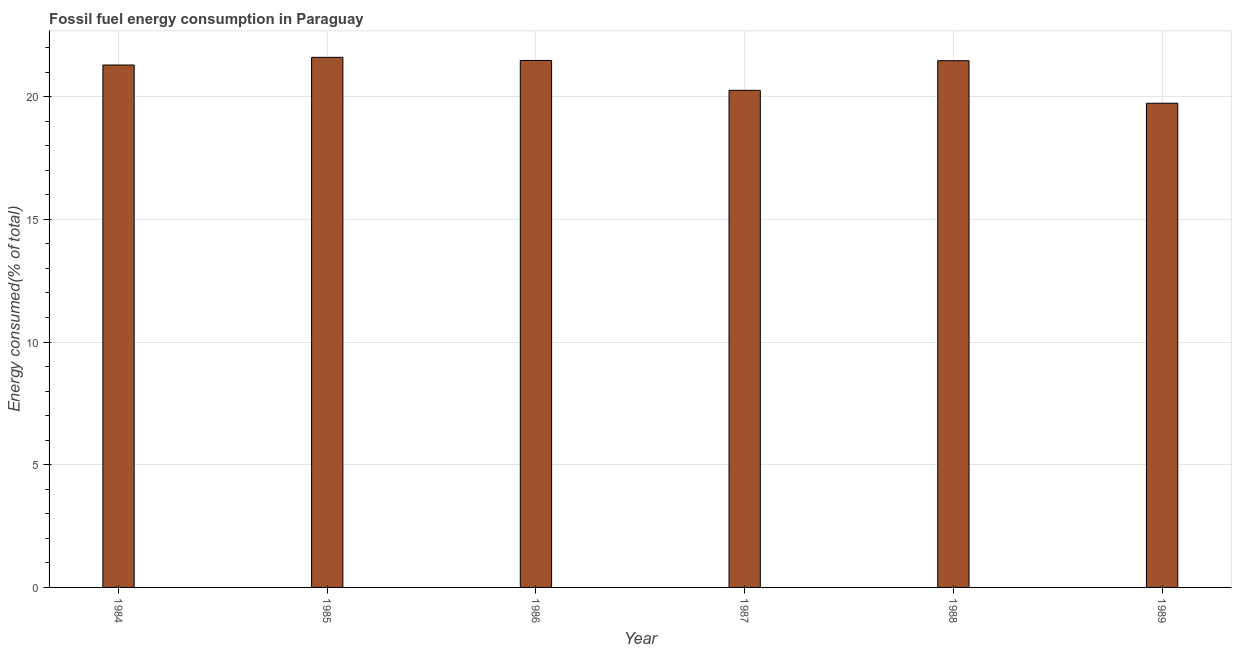What is the title of the graph?
Make the answer very short. Fossil fuel energy consumption in Paraguay. What is the label or title of the X-axis?
Keep it short and to the point. Year. What is the label or title of the Y-axis?
Your response must be concise. Energy consumed(% of total). What is the fossil fuel energy consumption in 1984?
Make the answer very short. 21.29. Across all years, what is the maximum fossil fuel energy consumption?
Your answer should be very brief. 21.6. Across all years, what is the minimum fossil fuel energy consumption?
Ensure brevity in your answer.  19.73. In which year was the fossil fuel energy consumption minimum?
Your answer should be compact. 1989. What is the sum of the fossil fuel energy consumption?
Ensure brevity in your answer.  125.81. What is the difference between the fossil fuel energy consumption in 1984 and 1986?
Offer a very short reply. -0.19. What is the average fossil fuel energy consumption per year?
Give a very brief answer. 20.97. What is the median fossil fuel energy consumption?
Offer a terse response. 21.38. In how many years, is the fossil fuel energy consumption greater than 11 %?
Provide a short and direct response. 6. Do a majority of the years between 1987 and 1985 (inclusive) have fossil fuel energy consumption greater than 11 %?
Keep it short and to the point. Yes. Is the fossil fuel energy consumption in 1984 less than that in 1985?
Make the answer very short. Yes. Is the difference between the fossil fuel energy consumption in 1985 and 1989 greater than the difference between any two years?
Offer a very short reply. Yes. What is the difference between the highest and the second highest fossil fuel energy consumption?
Your answer should be compact. 0.13. Is the sum of the fossil fuel energy consumption in 1986 and 1989 greater than the maximum fossil fuel energy consumption across all years?
Make the answer very short. Yes. What is the difference between the highest and the lowest fossil fuel energy consumption?
Your answer should be very brief. 1.87. In how many years, is the fossil fuel energy consumption greater than the average fossil fuel energy consumption taken over all years?
Offer a terse response. 4. Are the values on the major ticks of Y-axis written in scientific E-notation?
Your answer should be very brief. No. What is the Energy consumed(% of total) of 1984?
Offer a very short reply. 21.29. What is the Energy consumed(% of total) of 1985?
Keep it short and to the point. 21.6. What is the Energy consumed(% of total) of 1986?
Ensure brevity in your answer.  21.47. What is the Energy consumed(% of total) of 1987?
Ensure brevity in your answer.  20.26. What is the Energy consumed(% of total) of 1988?
Give a very brief answer. 21.46. What is the Energy consumed(% of total) in 1989?
Your response must be concise. 19.73. What is the difference between the Energy consumed(% of total) in 1984 and 1985?
Offer a terse response. -0.31. What is the difference between the Energy consumed(% of total) in 1984 and 1986?
Your response must be concise. -0.19. What is the difference between the Energy consumed(% of total) in 1984 and 1987?
Your answer should be very brief. 1.03. What is the difference between the Energy consumed(% of total) in 1984 and 1988?
Your response must be concise. -0.18. What is the difference between the Energy consumed(% of total) in 1984 and 1989?
Give a very brief answer. 1.56. What is the difference between the Energy consumed(% of total) in 1985 and 1986?
Provide a short and direct response. 0.13. What is the difference between the Energy consumed(% of total) in 1985 and 1987?
Offer a terse response. 1.34. What is the difference between the Energy consumed(% of total) in 1985 and 1988?
Offer a terse response. 0.14. What is the difference between the Energy consumed(% of total) in 1985 and 1989?
Offer a terse response. 1.87. What is the difference between the Energy consumed(% of total) in 1986 and 1987?
Keep it short and to the point. 1.22. What is the difference between the Energy consumed(% of total) in 1986 and 1988?
Ensure brevity in your answer.  0.01. What is the difference between the Energy consumed(% of total) in 1986 and 1989?
Offer a very short reply. 1.74. What is the difference between the Energy consumed(% of total) in 1987 and 1988?
Your response must be concise. -1.21. What is the difference between the Energy consumed(% of total) in 1987 and 1989?
Your response must be concise. 0.53. What is the difference between the Energy consumed(% of total) in 1988 and 1989?
Provide a short and direct response. 1.73. What is the ratio of the Energy consumed(% of total) in 1984 to that in 1985?
Make the answer very short. 0.99. What is the ratio of the Energy consumed(% of total) in 1984 to that in 1987?
Your answer should be very brief. 1.05. What is the ratio of the Energy consumed(% of total) in 1984 to that in 1988?
Ensure brevity in your answer.  0.99. What is the ratio of the Energy consumed(% of total) in 1984 to that in 1989?
Provide a succinct answer. 1.08. What is the ratio of the Energy consumed(% of total) in 1985 to that in 1987?
Your response must be concise. 1.07. What is the ratio of the Energy consumed(% of total) in 1985 to that in 1989?
Offer a terse response. 1.09. What is the ratio of the Energy consumed(% of total) in 1986 to that in 1987?
Offer a very short reply. 1.06. What is the ratio of the Energy consumed(% of total) in 1986 to that in 1989?
Your answer should be very brief. 1.09. What is the ratio of the Energy consumed(% of total) in 1987 to that in 1988?
Offer a terse response. 0.94. What is the ratio of the Energy consumed(% of total) in 1988 to that in 1989?
Keep it short and to the point. 1.09. 